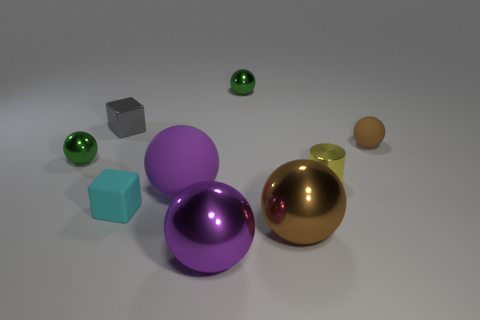Subtract all purple metallic balls. How many balls are left? 5 Add 2 tiny objects. How many tiny objects exist? 8 Subtract all gray blocks. How many blocks are left? 1 Subtract 1 gray blocks. How many objects are left? 8 Subtract all blocks. How many objects are left? 7 Subtract 6 spheres. How many spheres are left? 0 Subtract all blue cubes. Subtract all cyan cylinders. How many cubes are left? 2 Subtract all red cubes. How many green spheres are left? 2 Subtract all rubber objects. Subtract all large shiny balls. How many objects are left? 4 Add 1 small cubes. How many small cubes are left? 3 